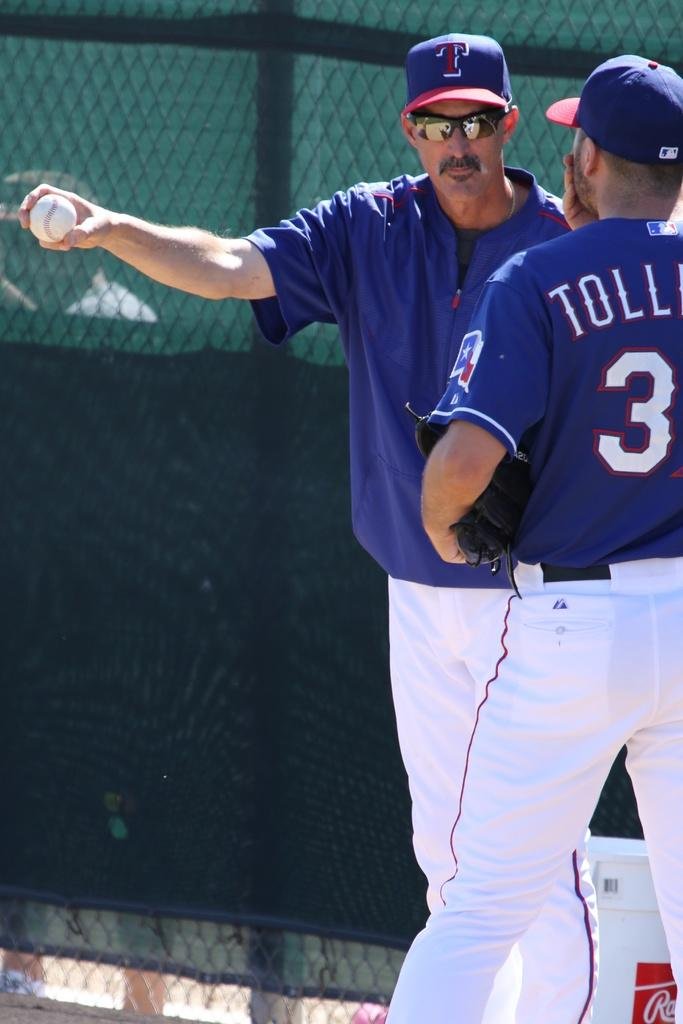<image>
Share a concise interpretation of the image provided. Ball player wearing blue and white uniform with TOLL in white letters on the back. 